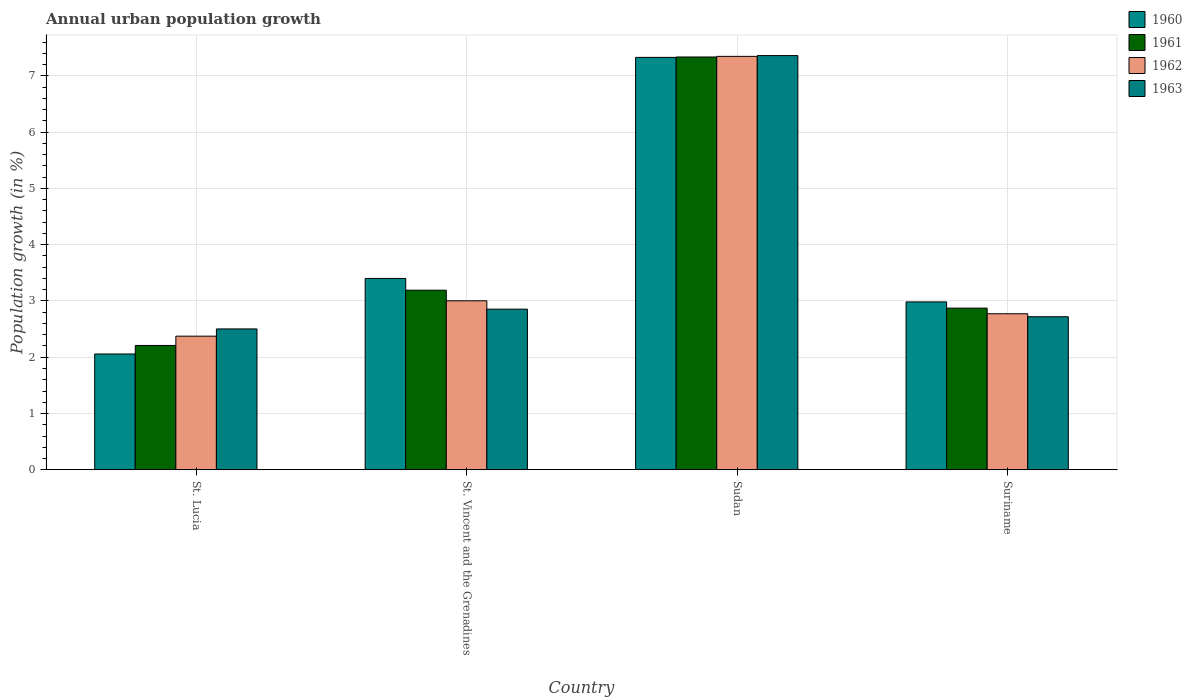How many different coloured bars are there?
Offer a terse response. 4. Are the number of bars per tick equal to the number of legend labels?
Provide a short and direct response. Yes. How many bars are there on the 2nd tick from the left?
Your answer should be very brief. 4. How many bars are there on the 3rd tick from the right?
Offer a terse response. 4. What is the label of the 4th group of bars from the left?
Provide a short and direct response. Suriname. In how many cases, is the number of bars for a given country not equal to the number of legend labels?
Your answer should be very brief. 0. What is the percentage of urban population growth in 1962 in St. Lucia?
Give a very brief answer. 2.37. Across all countries, what is the maximum percentage of urban population growth in 1961?
Offer a terse response. 7.34. Across all countries, what is the minimum percentage of urban population growth in 1960?
Make the answer very short. 2.06. In which country was the percentage of urban population growth in 1962 maximum?
Provide a short and direct response. Sudan. In which country was the percentage of urban population growth in 1963 minimum?
Keep it short and to the point. St. Lucia. What is the total percentage of urban population growth in 1960 in the graph?
Offer a very short reply. 15.77. What is the difference between the percentage of urban population growth in 1961 in St. Vincent and the Grenadines and that in Suriname?
Offer a very short reply. 0.32. What is the difference between the percentage of urban population growth in 1963 in St. Vincent and the Grenadines and the percentage of urban population growth in 1961 in Suriname?
Offer a very short reply. -0.02. What is the average percentage of urban population growth in 1960 per country?
Provide a short and direct response. 3.94. What is the difference between the percentage of urban population growth of/in 1961 and percentage of urban population growth of/in 1963 in St. Vincent and the Grenadines?
Provide a short and direct response. 0.34. In how many countries, is the percentage of urban population growth in 1963 greater than 6.4 %?
Keep it short and to the point. 1. What is the ratio of the percentage of urban population growth in 1960 in St. Vincent and the Grenadines to that in Sudan?
Ensure brevity in your answer.  0.46. Is the percentage of urban population growth in 1962 in St. Vincent and the Grenadines less than that in Sudan?
Your answer should be compact. Yes. Is the difference between the percentage of urban population growth in 1961 in St. Lucia and St. Vincent and the Grenadines greater than the difference between the percentage of urban population growth in 1963 in St. Lucia and St. Vincent and the Grenadines?
Give a very brief answer. No. What is the difference between the highest and the second highest percentage of urban population growth in 1963?
Give a very brief answer. 0.13. What is the difference between the highest and the lowest percentage of urban population growth in 1962?
Keep it short and to the point. 4.97. What does the 1st bar from the right in St. Vincent and the Grenadines represents?
Your response must be concise. 1963. Does the graph contain any zero values?
Ensure brevity in your answer.  No. What is the title of the graph?
Your answer should be compact. Annual urban population growth. Does "1973" appear as one of the legend labels in the graph?
Provide a succinct answer. No. What is the label or title of the Y-axis?
Your response must be concise. Population growth (in %). What is the Population growth (in %) of 1960 in St. Lucia?
Offer a very short reply. 2.06. What is the Population growth (in %) of 1961 in St. Lucia?
Your answer should be very brief. 2.21. What is the Population growth (in %) in 1962 in St. Lucia?
Your answer should be compact. 2.37. What is the Population growth (in %) of 1963 in St. Lucia?
Offer a terse response. 2.5. What is the Population growth (in %) in 1960 in St. Vincent and the Grenadines?
Offer a very short reply. 3.4. What is the Population growth (in %) of 1961 in St. Vincent and the Grenadines?
Give a very brief answer. 3.19. What is the Population growth (in %) of 1962 in St. Vincent and the Grenadines?
Ensure brevity in your answer.  3. What is the Population growth (in %) in 1963 in St. Vincent and the Grenadines?
Your response must be concise. 2.85. What is the Population growth (in %) of 1960 in Sudan?
Offer a very short reply. 7.33. What is the Population growth (in %) of 1961 in Sudan?
Your response must be concise. 7.34. What is the Population growth (in %) in 1962 in Sudan?
Give a very brief answer. 7.35. What is the Population growth (in %) of 1963 in Sudan?
Make the answer very short. 7.36. What is the Population growth (in %) of 1960 in Suriname?
Offer a very short reply. 2.98. What is the Population growth (in %) in 1961 in Suriname?
Offer a terse response. 2.87. What is the Population growth (in %) in 1962 in Suriname?
Provide a succinct answer. 2.77. What is the Population growth (in %) in 1963 in Suriname?
Your answer should be compact. 2.72. Across all countries, what is the maximum Population growth (in %) in 1960?
Provide a succinct answer. 7.33. Across all countries, what is the maximum Population growth (in %) of 1961?
Your answer should be very brief. 7.34. Across all countries, what is the maximum Population growth (in %) in 1962?
Provide a succinct answer. 7.35. Across all countries, what is the maximum Population growth (in %) of 1963?
Give a very brief answer. 7.36. Across all countries, what is the minimum Population growth (in %) in 1960?
Give a very brief answer. 2.06. Across all countries, what is the minimum Population growth (in %) in 1961?
Your answer should be compact. 2.21. Across all countries, what is the minimum Population growth (in %) of 1962?
Offer a very short reply. 2.37. Across all countries, what is the minimum Population growth (in %) of 1963?
Provide a short and direct response. 2.5. What is the total Population growth (in %) in 1960 in the graph?
Your answer should be compact. 15.77. What is the total Population growth (in %) in 1961 in the graph?
Offer a terse response. 15.61. What is the total Population growth (in %) of 1962 in the graph?
Keep it short and to the point. 15.5. What is the total Population growth (in %) in 1963 in the graph?
Offer a terse response. 15.44. What is the difference between the Population growth (in %) of 1960 in St. Lucia and that in St. Vincent and the Grenadines?
Offer a very short reply. -1.34. What is the difference between the Population growth (in %) in 1961 in St. Lucia and that in St. Vincent and the Grenadines?
Offer a terse response. -0.98. What is the difference between the Population growth (in %) in 1962 in St. Lucia and that in St. Vincent and the Grenadines?
Give a very brief answer. -0.63. What is the difference between the Population growth (in %) of 1963 in St. Lucia and that in St. Vincent and the Grenadines?
Give a very brief answer. -0.35. What is the difference between the Population growth (in %) in 1960 in St. Lucia and that in Sudan?
Offer a very short reply. -5.27. What is the difference between the Population growth (in %) in 1961 in St. Lucia and that in Sudan?
Offer a very short reply. -5.13. What is the difference between the Population growth (in %) in 1962 in St. Lucia and that in Sudan?
Offer a very short reply. -4.97. What is the difference between the Population growth (in %) in 1963 in St. Lucia and that in Sudan?
Offer a terse response. -4.86. What is the difference between the Population growth (in %) in 1960 in St. Lucia and that in Suriname?
Provide a short and direct response. -0.93. What is the difference between the Population growth (in %) in 1961 in St. Lucia and that in Suriname?
Your response must be concise. -0.66. What is the difference between the Population growth (in %) of 1962 in St. Lucia and that in Suriname?
Keep it short and to the point. -0.4. What is the difference between the Population growth (in %) in 1963 in St. Lucia and that in Suriname?
Ensure brevity in your answer.  -0.22. What is the difference between the Population growth (in %) in 1960 in St. Vincent and the Grenadines and that in Sudan?
Ensure brevity in your answer.  -3.93. What is the difference between the Population growth (in %) in 1961 in St. Vincent and the Grenadines and that in Sudan?
Offer a very short reply. -4.14. What is the difference between the Population growth (in %) of 1962 in St. Vincent and the Grenadines and that in Sudan?
Offer a very short reply. -4.34. What is the difference between the Population growth (in %) in 1963 in St. Vincent and the Grenadines and that in Sudan?
Your answer should be compact. -4.51. What is the difference between the Population growth (in %) of 1960 in St. Vincent and the Grenadines and that in Suriname?
Your response must be concise. 0.42. What is the difference between the Population growth (in %) of 1961 in St. Vincent and the Grenadines and that in Suriname?
Provide a short and direct response. 0.32. What is the difference between the Population growth (in %) of 1962 in St. Vincent and the Grenadines and that in Suriname?
Keep it short and to the point. 0.23. What is the difference between the Population growth (in %) in 1963 in St. Vincent and the Grenadines and that in Suriname?
Offer a very short reply. 0.13. What is the difference between the Population growth (in %) of 1960 in Sudan and that in Suriname?
Ensure brevity in your answer.  4.35. What is the difference between the Population growth (in %) of 1961 in Sudan and that in Suriname?
Offer a very short reply. 4.46. What is the difference between the Population growth (in %) in 1962 in Sudan and that in Suriname?
Your response must be concise. 4.57. What is the difference between the Population growth (in %) in 1963 in Sudan and that in Suriname?
Your answer should be compact. 4.64. What is the difference between the Population growth (in %) of 1960 in St. Lucia and the Population growth (in %) of 1961 in St. Vincent and the Grenadines?
Provide a short and direct response. -1.13. What is the difference between the Population growth (in %) in 1960 in St. Lucia and the Population growth (in %) in 1962 in St. Vincent and the Grenadines?
Offer a terse response. -0.95. What is the difference between the Population growth (in %) in 1960 in St. Lucia and the Population growth (in %) in 1963 in St. Vincent and the Grenadines?
Offer a very short reply. -0.8. What is the difference between the Population growth (in %) in 1961 in St. Lucia and the Population growth (in %) in 1962 in St. Vincent and the Grenadines?
Keep it short and to the point. -0.79. What is the difference between the Population growth (in %) of 1961 in St. Lucia and the Population growth (in %) of 1963 in St. Vincent and the Grenadines?
Give a very brief answer. -0.65. What is the difference between the Population growth (in %) in 1962 in St. Lucia and the Population growth (in %) in 1963 in St. Vincent and the Grenadines?
Provide a short and direct response. -0.48. What is the difference between the Population growth (in %) in 1960 in St. Lucia and the Population growth (in %) in 1961 in Sudan?
Ensure brevity in your answer.  -5.28. What is the difference between the Population growth (in %) of 1960 in St. Lucia and the Population growth (in %) of 1962 in Sudan?
Give a very brief answer. -5.29. What is the difference between the Population growth (in %) in 1960 in St. Lucia and the Population growth (in %) in 1963 in Sudan?
Ensure brevity in your answer.  -5.3. What is the difference between the Population growth (in %) of 1961 in St. Lucia and the Population growth (in %) of 1962 in Sudan?
Give a very brief answer. -5.14. What is the difference between the Population growth (in %) in 1961 in St. Lucia and the Population growth (in %) in 1963 in Sudan?
Your response must be concise. -5.15. What is the difference between the Population growth (in %) in 1962 in St. Lucia and the Population growth (in %) in 1963 in Sudan?
Provide a succinct answer. -4.99. What is the difference between the Population growth (in %) in 1960 in St. Lucia and the Population growth (in %) in 1961 in Suriname?
Your answer should be very brief. -0.81. What is the difference between the Population growth (in %) in 1960 in St. Lucia and the Population growth (in %) in 1962 in Suriname?
Provide a succinct answer. -0.72. What is the difference between the Population growth (in %) of 1960 in St. Lucia and the Population growth (in %) of 1963 in Suriname?
Give a very brief answer. -0.66. What is the difference between the Population growth (in %) in 1961 in St. Lucia and the Population growth (in %) in 1962 in Suriname?
Offer a terse response. -0.56. What is the difference between the Population growth (in %) of 1961 in St. Lucia and the Population growth (in %) of 1963 in Suriname?
Keep it short and to the point. -0.51. What is the difference between the Population growth (in %) of 1962 in St. Lucia and the Population growth (in %) of 1963 in Suriname?
Give a very brief answer. -0.35. What is the difference between the Population growth (in %) of 1960 in St. Vincent and the Grenadines and the Population growth (in %) of 1961 in Sudan?
Give a very brief answer. -3.94. What is the difference between the Population growth (in %) of 1960 in St. Vincent and the Grenadines and the Population growth (in %) of 1962 in Sudan?
Make the answer very short. -3.95. What is the difference between the Population growth (in %) of 1960 in St. Vincent and the Grenadines and the Population growth (in %) of 1963 in Sudan?
Your answer should be compact. -3.96. What is the difference between the Population growth (in %) in 1961 in St. Vincent and the Grenadines and the Population growth (in %) in 1962 in Sudan?
Give a very brief answer. -4.16. What is the difference between the Population growth (in %) in 1961 in St. Vincent and the Grenadines and the Population growth (in %) in 1963 in Sudan?
Provide a short and direct response. -4.17. What is the difference between the Population growth (in %) in 1962 in St. Vincent and the Grenadines and the Population growth (in %) in 1963 in Sudan?
Your answer should be very brief. -4.36. What is the difference between the Population growth (in %) in 1960 in St. Vincent and the Grenadines and the Population growth (in %) in 1961 in Suriname?
Give a very brief answer. 0.53. What is the difference between the Population growth (in %) of 1960 in St. Vincent and the Grenadines and the Population growth (in %) of 1962 in Suriname?
Your answer should be compact. 0.63. What is the difference between the Population growth (in %) in 1960 in St. Vincent and the Grenadines and the Population growth (in %) in 1963 in Suriname?
Provide a succinct answer. 0.68. What is the difference between the Population growth (in %) in 1961 in St. Vincent and the Grenadines and the Population growth (in %) in 1962 in Suriname?
Your answer should be very brief. 0.42. What is the difference between the Population growth (in %) in 1961 in St. Vincent and the Grenadines and the Population growth (in %) in 1963 in Suriname?
Offer a terse response. 0.47. What is the difference between the Population growth (in %) in 1962 in St. Vincent and the Grenadines and the Population growth (in %) in 1963 in Suriname?
Your answer should be very brief. 0.28. What is the difference between the Population growth (in %) of 1960 in Sudan and the Population growth (in %) of 1961 in Suriname?
Provide a succinct answer. 4.46. What is the difference between the Population growth (in %) of 1960 in Sudan and the Population growth (in %) of 1962 in Suriname?
Offer a very short reply. 4.56. What is the difference between the Population growth (in %) in 1960 in Sudan and the Population growth (in %) in 1963 in Suriname?
Ensure brevity in your answer.  4.61. What is the difference between the Population growth (in %) of 1961 in Sudan and the Population growth (in %) of 1962 in Suriname?
Make the answer very short. 4.56. What is the difference between the Population growth (in %) in 1961 in Sudan and the Population growth (in %) in 1963 in Suriname?
Offer a terse response. 4.62. What is the difference between the Population growth (in %) in 1962 in Sudan and the Population growth (in %) in 1963 in Suriname?
Ensure brevity in your answer.  4.63. What is the average Population growth (in %) of 1960 per country?
Ensure brevity in your answer.  3.94. What is the average Population growth (in %) in 1961 per country?
Make the answer very short. 3.9. What is the average Population growth (in %) of 1962 per country?
Ensure brevity in your answer.  3.87. What is the average Population growth (in %) of 1963 per country?
Offer a very short reply. 3.86. What is the difference between the Population growth (in %) of 1960 and Population growth (in %) of 1961 in St. Lucia?
Offer a terse response. -0.15. What is the difference between the Population growth (in %) of 1960 and Population growth (in %) of 1962 in St. Lucia?
Give a very brief answer. -0.32. What is the difference between the Population growth (in %) of 1960 and Population growth (in %) of 1963 in St. Lucia?
Give a very brief answer. -0.45. What is the difference between the Population growth (in %) of 1961 and Population growth (in %) of 1962 in St. Lucia?
Give a very brief answer. -0.17. What is the difference between the Population growth (in %) of 1961 and Population growth (in %) of 1963 in St. Lucia?
Provide a succinct answer. -0.29. What is the difference between the Population growth (in %) in 1962 and Population growth (in %) in 1963 in St. Lucia?
Your answer should be very brief. -0.13. What is the difference between the Population growth (in %) in 1960 and Population growth (in %) in 1961 in St. Vincent and the Grenadines?
Provide a succinct answer. 0.21. What is the difference between the Population growth (in %) of 1960 and Population growth (in %) of 1962 in St. Vincent and the Grenadines?
Offer a very short reply. 0.4. What is the difference between the Population growth (in %) in 1960 and Population growth (in %) in 1963 in St. Vincent and the Grenadines?
Your response must be concise. 0.55. What is the difference between the Population growth (in %) of 1961 and Population growth (in %) of 1962 in St. Vincent and the Grenadines?
Make the answer very short. 0.19. What is the difference between the Population growth (in %) of 1961 and Population growth (in %) of 1963 in St. Vincent and the Grenadines?
Make the answer very short. 0.34. What is the difference between the Population growth (in %) in 1962 and Population growth (in %) in 1963 in St. Vincent and the Grenadines?
Your answer should be very brief. 0.15. What is the difference between the Population growth (in %) in 1960 and Population growth (in %) in 1961 in Sudan?
Your response must be concise. -0.01. What is the difference between the Population growth (in %) of 1960 and Population growth (in %) of 1962 in Sudan?
Your answer should be very brief. -0.02. What is the difference between the Population growth (in %) in 1960 and Population growth (in %) in 1963 in Sudan?
Make the answer very short. -0.03. What is the difference between the Population growth (in %) in 1961 and Population growth (in %) in 1962 in Sudan?
Keep it short and to the point. -0.01. What is the difference between the Population growth (in %) of 1961 and Population growth (in %) of 1963 in Sudan?
Your answer should be compact. -0.02. What is the difference between the Population growth (in %) of 1962 and Population growth (in %) of 1963 in Sudan?
Ensure brevity in your answer.  -0.01. What is the difference between the Population growth (in %) of 1960 and Population growth (in %) of 1961 in Suriname?
Ensure brevity in your answer.  0.11. What is the difference between the Population growth (in %) of 1960 and Population growth (in %) of 1962 in Suriname?
Your answer should be very brief. 0.21. What is the difference between the Population growth (in %) in 1960 and Population growth (in %) in 1963 in Suriname?
Make the answer very short. 0.26. What is the difference between the Population growth (in %) in 1961 and Population growth (in %) in 1962 in Suriname?
Offer a terse response. 0.1. What is the difference between the Population growth (in %) in 1961 and Population growth (in %) in 1963 in Suriname?
Give a very brief answer. 0.15. What is the difference between the Population growth (in %) of 1962 and Population growth (in %) of 1963 in Suriname?
Your answer should be very brief. 0.05. What is the ratio of the Population growth (in %) of 1960 in St. Lucia to that in St. Vincent and the Grenadines?
Your answer should be compact. 0.61. What is the ratio of the Population growth (in %) in 1961 in St. Lucia to that in St. Vincent and the Grenadines?
Give a very brief answer. 0.69. What is the ratio of the Population growth (in %) in 1962 in St. Lucia to that in St. Vincent and the Grenadines?
Your answer should be very brief. 0.79. What is the ratio of the Population growth (in %) in 1963 in St. Lucia to that in St. Vincent and the Grenadines?
Your answer should be compact. 0.88. What is the ratio of the Population growth (in %) of 1960 in St. Lucia to that in Sudan?
Make the answer very short. 0.28. What is the ratio of the Population growth (in %) in 1961 in St. Lucia to that in Sudan?
Provide a succinct answer. 0.3. What is the ratio of the Population growth (in %) of 1962 in St. Lucia to that in Sudan?
Keep it short and to the point. 0.32. What is the ratio of the Population growth (in %) of 1963 in St. Lucia to that in Sudan?
Offer a terse response. 0.34. What is the ratio of the Population growth (in %) of 1960 in St. Lucia to that in Suriname?
Offer a very short reply. 0.69. What is the ratio of the Population growth (in %) of 1961 in St. Lucia to that in Suriname?
Offer a terse response. 0.77. What is the ratio of the Population growth (in %) in 1962 in St. Lucia to that in Suriname?
Offer a very short reply. 0.86. What is the ratio of the Population growth (in %) of 1963 in St. Lucia to that in Suriname?
Make the answer very short. 0.92. What is the ratio of the Population growth (in %) in 1960 in St. Vincent and the Grenadines to that in Sudan?
Your response must be concise. 0.46. What is the ratio of the Population growth (in %) of 1961 in St. Vincent and the Grenadines to that in Sudan?
Make the answer very short. 0.44. What is the ratio of the Population growth (in %) of 1962 in St. Vincent and the Grenadines to that in Sudan?
Your response must be concise. 0.41. What is the ratio of the Population growth (in %) of 1963 in St. Vincent and the Grenadines to that in Sudan?
Offer a very short reply. 0.39. What is the ratio of the Population growth (in %) of 1960 in St. Vincent and the Grenadines to that in Suriname?
Ensure brevity in your answer.  1.14. What is the ratio of the Population growth (in %) of 1961 in St. Vincent and the Grenadines to that in Suriname?
Your response must be concise. 1.11. What is the ratio of the Population growth (in %) of 1962 in St. Vincent and the Grenadines to that in Suriname?
Provide a succinct answer. 1.08. What is the ratio of the Population growth (in %) in 1963 in St. Vincent and the Grenadines to that in Suriname?
Provide a short and direct response. 1.05. What is the ratio of the Population growth (in %) of 1960 in Sudan to that in Suriname?
Your answer should be compact. 2.46. What is the ratio of the Population growth (in %) in 1961 in Sudan to that in Suriname?
Your answer should be compact. 2.55. What is the ratio of the Population growth (in %) of 1962 in Sudan to that in Suriname?
Offer a very short reply. 2.65. What is the ratio of the Population growth (in %) of 1963 in Sudan to that in Suriname?
Your answer should be very brief. 2.71. What is the difference between the highest and the second highest Population growth (in %) in 1960?
Provide a succinct answer. 3.93. What is the difference between the highest and the second highest Population growth (in %) in 1961?
Your answer should be compact. 4.14. What is the difference between the highest and the second highest Population growth (in %) in 1962?
Your answer should be very brief. 4.34. What is the difference between the highest and the second highest Population growth (in %) in 1963?
Offer a very short reply. 4.51. What is the difference between the highest and the lowest Population growth (in %) of 1960?
Your answer should be compact. 5.27. What is the difference between the highest and the lowest Population growth (in %) of 1961?
Provide a succinct answer. 5.13. What is the difference between the highest and the lowest Population growth (in %) in 1962?
Make the answer very short. 4.97. What is the difference between the highest and the lowest Population growth (in %) of 1963?
Give a very brief answer. 4.86. 